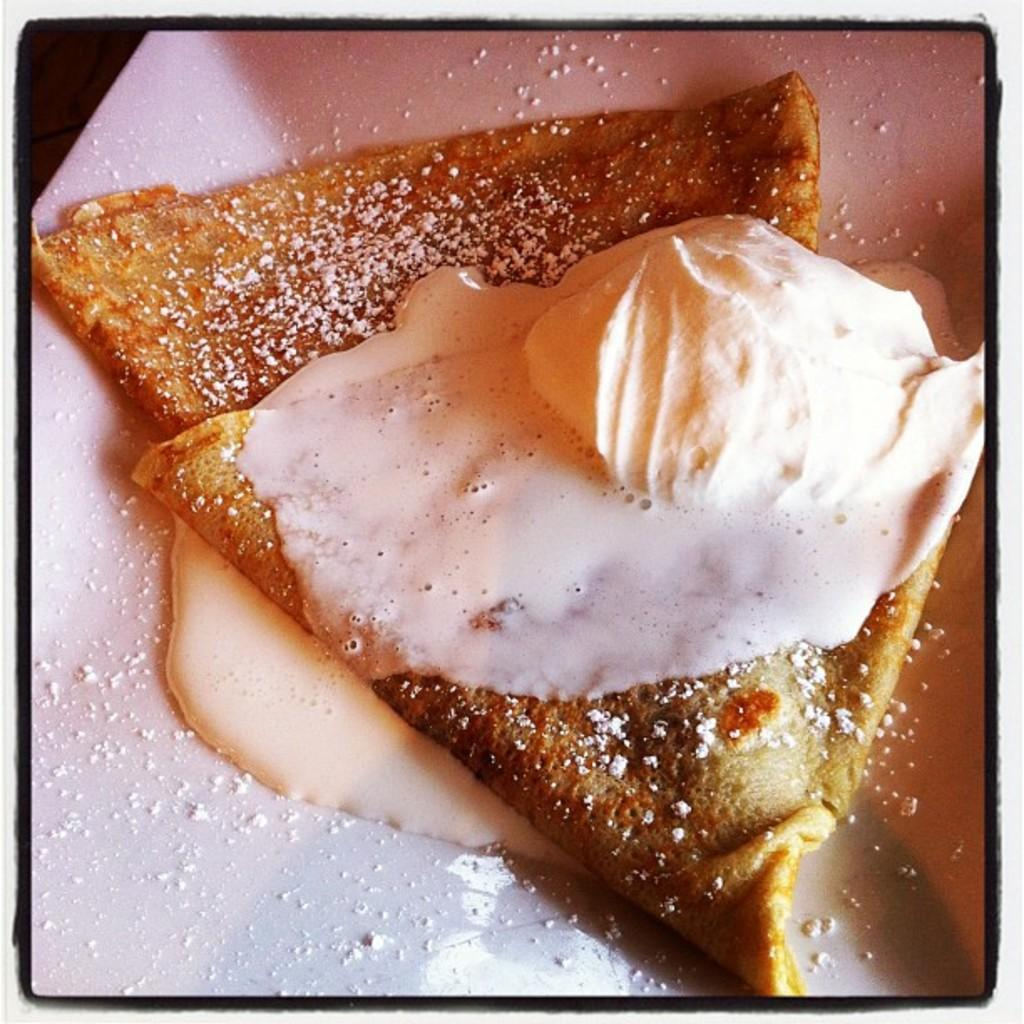What is on the plate that is visible in the image? There is a plate with food in the image. What type of voice can be heard coming from the food on the plate? There is no voice coming from the food on the plate, as food does not have the ability to produce sound. 